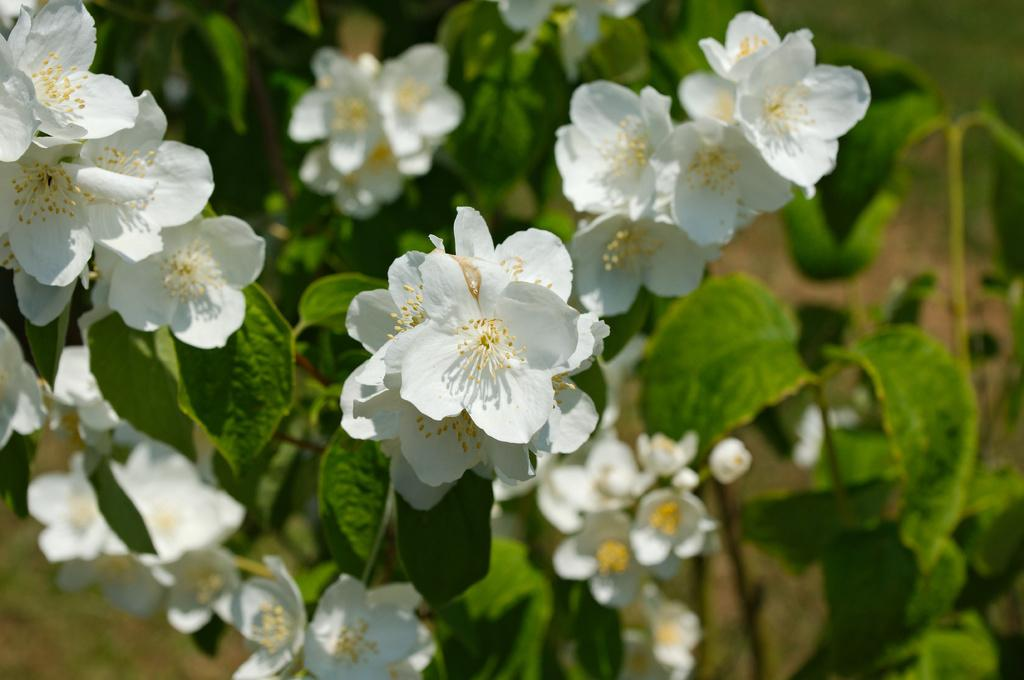What type of plants are present in the image? There are flowers in the image, which are on plants that are green in color. What colors are the flowers in the image? The flowers are white and yellow in color. What can be observed about the background of the image? The background of the image is blurry, and the background colors are green and brown. What type of book is being read by the flowers in the image? There are no books or people present in the image; it features flowers on plants. 